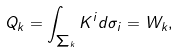Convert formula to latex. <formula><loc_0><loc_0><loc_500><loc_500>Q _ { k } = \int _ { \sum _ { k } } K ^ { i } d \sigma _ { i } = W _ { k } ,</formula> 